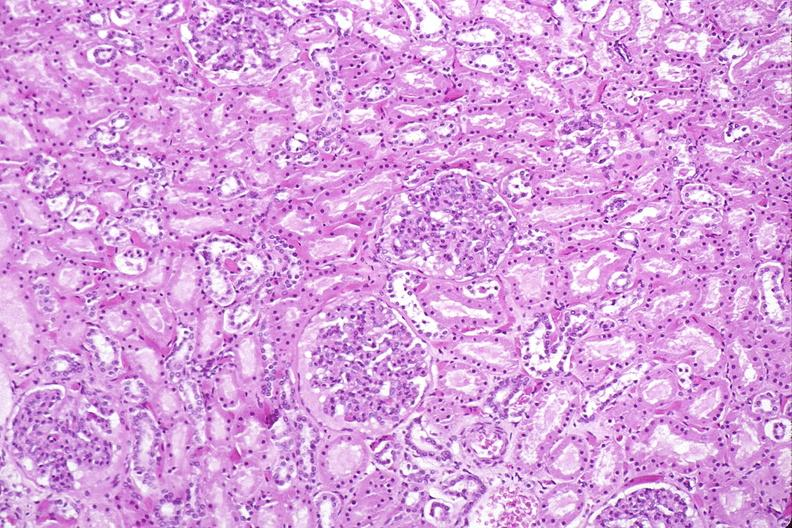where is this?
Answer the question using a single word or phrase. Urinary 